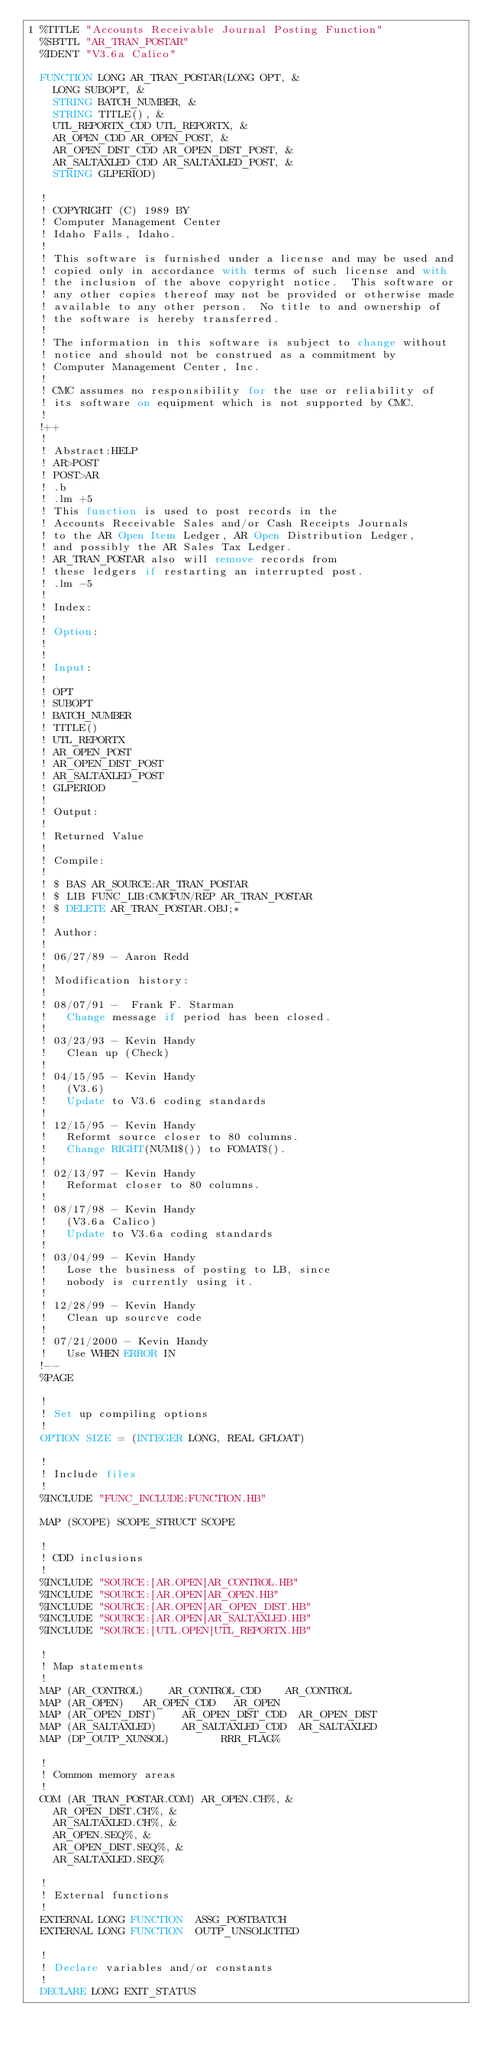Convert code to text. <code><loc_0><loc_0><loc_500><loc_500><_VisualBasic_>1	%TITLE "Accounts Receivable Journal Posting Function"
	%SBTTL "AR_TRAN_POSTAR"
	%IDENT "V3.6a Calico"

	FUNCTION LONG AR_TRAN_POSTAR(LONG OPT, &
		LONG SUBOPT, &
		STRING BATCH_NUMBER, &
		STRING TITLE(), &
		UTL_REPORTX_CDD UTL_REPORTX, &
		AR_OPEN_CDD AR_OPEN_POST, &
		AR_OPEN_DIST_CDD AR_OPEN_DIST_POST, &
		AR_SALTAXLED_CDD AR_SALTAXLED_POST, &
		STRING GLPERIOD)

	!
	! COPYRIGHT (C) 1989 BY
	! Computer Management Center
	! Idaho Falls, Idaho.
	!
	! This software is furnished under a license and may be used and
	! copied only in accordance with terms of such license and with
	! the inclusion of the above copyright notice.  This software or
	! any other copies thereof may not be provided or otherwise made
	! available to any other person.  No title to and ownership of
	! the software is hereby transferred.
	!
	! The information in this software is subject to change without
	! notice and should not be construed as a commitment by
	! Computer Management Center, Inc.
	!
	! CMC assumes no responsibility for the use or reliability of
	! its software on equipment which is not supported by CMC.
	!
	!++
	!
	! Abstract:HELP
	!	AR>POST
	!	POST>AR
	!	.b
	!	.lm +5
	!	This function is used to post records in the
	!	Accounts Receivable Sales and/or Cash Receipts Journals
	!	to the AR Open Item Ledger, AR Open Distribution Ledger,
	!	and possibly the AR Sales Tax Ledger.
	!	AR_TRAN_POSTAR also will remove records from
	!	these ledgers if restarting an interrupted post.
	!	.lm -5
	!
	! Index:
	!
	! Option:
	!
	!
	! Input:
	!
	!	OPT
	!	SUBOPT
	!	BATCH_NUMBER
	!	TITLE()
	!	UTL_REPORTX
	!	AR_OPEN_POST
	!	AR_OPEN_DIST_POST
	!	AR_SALTAXLED_POST
	!	GLPERIOD
	!
	! Output:
	!
	!	Returned Value
	!
	! Compile:
	!
	!	$ BAS AR_SOURCE:AR_TRAN_POSTAR
	!	$ LIB FUNC_LIB:CMCFUN/REP AR_TRAN_POSTAR
	!	$ DELETE AR_TRAN_POSTAR.OBJ;*
	!
	! Author:
	!
	!	06/27/89 - Aaron Redd
	!
	! Modification history:
	!
	!	08/07/91 -  Frank F. Starman
	!		Change message if period has been closed.
	!
	!	03/23/93 - Kevin Handy
	!		Clean up (Check)
	!
	!	04/15/95 - Kevin Handy
	!		(V3.6)
	!		Update to V3.6 coding standards
	!
	!	12/15/95 - Kevin Handy
	!		Reformt source closer to 80 columns.
	!		Change RIGHT(NUM1$()) to FOMAT$().
	!
	!	02/13/97 - Kevin Handy
	!		Reformat closer to 80 columns.
	!
	!	08/17/98 - Kevin Handy
	!		(V3.6a Calico)
	!		Update to V3.6a coding standards
	!
	!	03/04/99 - Kevin Handy
	!		Lose the business of posting to LB, since
	!		nobody is currently using it.
	!
	!	12/28/99 - Kevin Handy
	!		Clean up sourcve code
	!
	!	07/21/2000 - Kevin Handy
	!		Use WHEN ERROR IN
	!--
	%PAGE

	!
	! Set up compiling options
	!
	OPTION SIZE = (INTEGER LONG, REAL GFLOAT)

	!
	! Include files
	!
	%INCLUDE "FUNC_INCLUDE:FUNCTION.HB"

	MAP (SCOPE) SCOPE_STRUCT SCOPE

	!
	! CDD inclusions
	!
	%INCLUDE "SOURCE:[AR.OPEN]AR_CONTROL.HB"
	%INCLUDE "SOURCE:[AR.OPEN]AR_OPEN.HB"
	%INCLUDE "SOURCE:[AR.OPEN]AR_OPEN_DIST.HB"
	%INCLUDE "SOURCE:[AR.OPEN]AR_SALTAXLED.HB"
	%INCLUDE "SOURCE:[UTL.OPEN]UTL_REPORTX.HB"

	!
	! Map statements
	!
	MAP	(AR_CONTROL)		AR_CONTROL_CDD		AR_CONTROL
	MAP	(AR_OPEN)		AR_OPEN_CDD		AR_OPEN
	MAP	(AR_OPEN_DIST)		AR_OPEN_DIST_CDD	AR_OPEN_DIST
	MAP	(AR_SALTAXLED)		AR_SALTAXLED_CDD	AR_SALTAXLED
	MAP	(DP_OUTP_XUNSOL)				RRR_FLAG%

	!
	! Common memory areas
	!
	COM (AR_TRAN_POSTAR.COM) AR_OPEN.CH%, &
		AR_OPEN_DIST.CH%, &
		AR_SALTAXLED.CH%, &
		AR_OPEN.SEQ%, &
		AR_OPEN_DIST.SEQ%, &
		AR_SALTAXLED.SEQ%

	!
	! External functions
	!
	EXTERNAL LONG	FUNCTION	ASSG_POSTBATCH
	EXTERNAL LONG	FUNCTION	OUTP_UNSOLICITED

	!
	! Declare variables and/or constants
	!
	DECLARE LONG EXIT_STATUS
</code> 